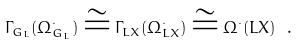Convert formula to latex. <formula><loc_0><loc_0><loc_500><loc_500>\Gamma _ { G _ { L } } ( \Omega ^ { \cdot } _ { G _ { L } } ) \cong \Gamma _ { L X } ( \Omega ^ { \cdot } _ { L X } ) \cong \Omega ^ { \cdot } ( L X ) \ .</formula> 